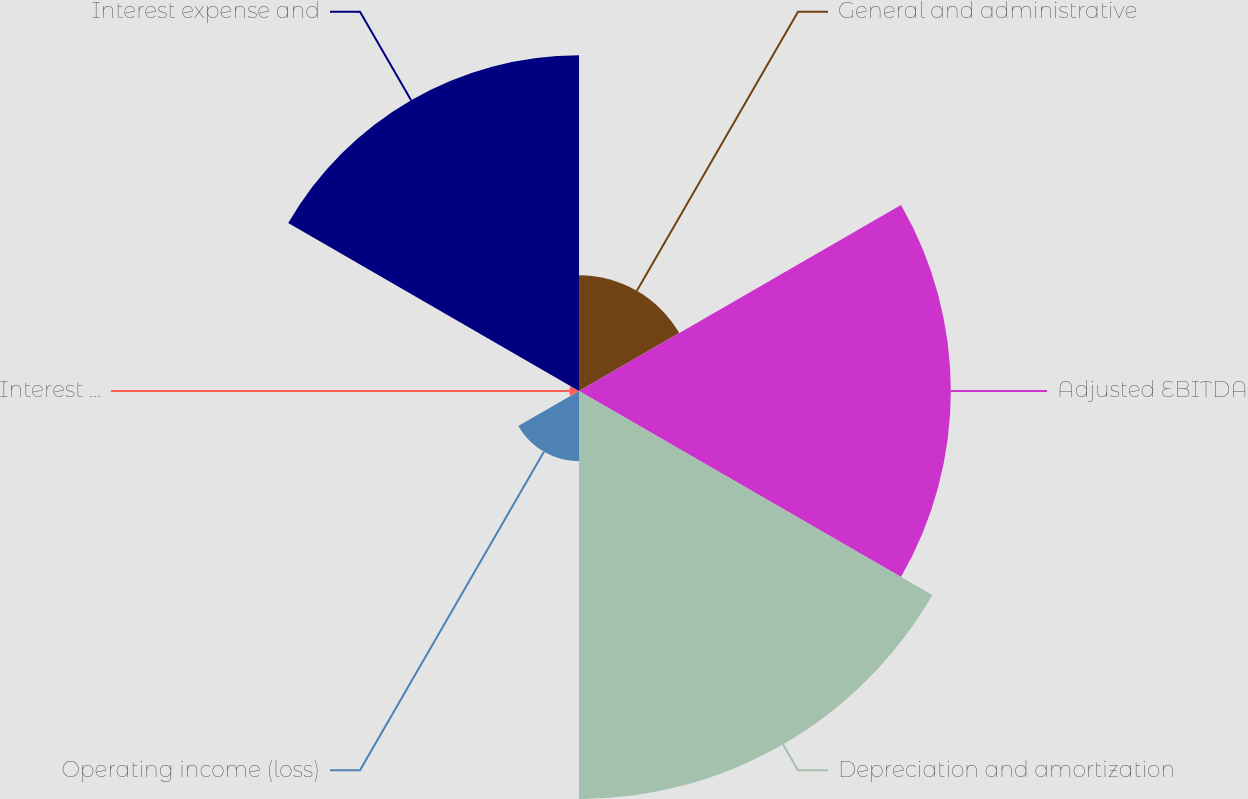Convert chart. <chart><loc_0><loc_0><loc_500><loc_500><pie_chart><fcel>General and administrative<fcel>Adjusted EBITDA<fcel>Depreciation and amortization<fcel>Operating income (loss)<fcel>Interest and other income<fcel>Interest expense and<nl><fcel>8.83%<fcel>28.36%<fcel>31.12%<fcel>5.35%<fcel>0.74%<fcel>25.61%<nl></chart> 